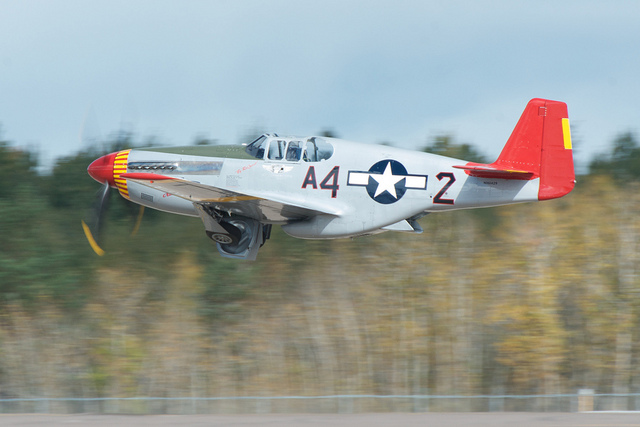Is this a jet aircraft? The aircraft in the image is actually a propeller-driven plane, as indicated by the visible propeller in the front and the absence of jet engines. 